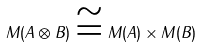<formula> <loc_0><loc_0><loc_500><loc_500>M ( A \otimes B ) \cong M ( A ) \times M ( B )</formula> 